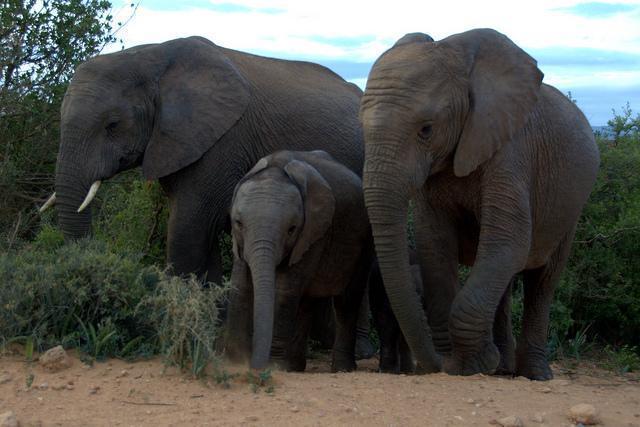What is the baby elephant called?
Choose the correct response and explain in the format: 'Answer: answer
Rationale: rationale.'
Options: Calf, bullock, kit, colt. Answer: calf.
Rationale: A baby elephant is called the same name as a baby cow. 